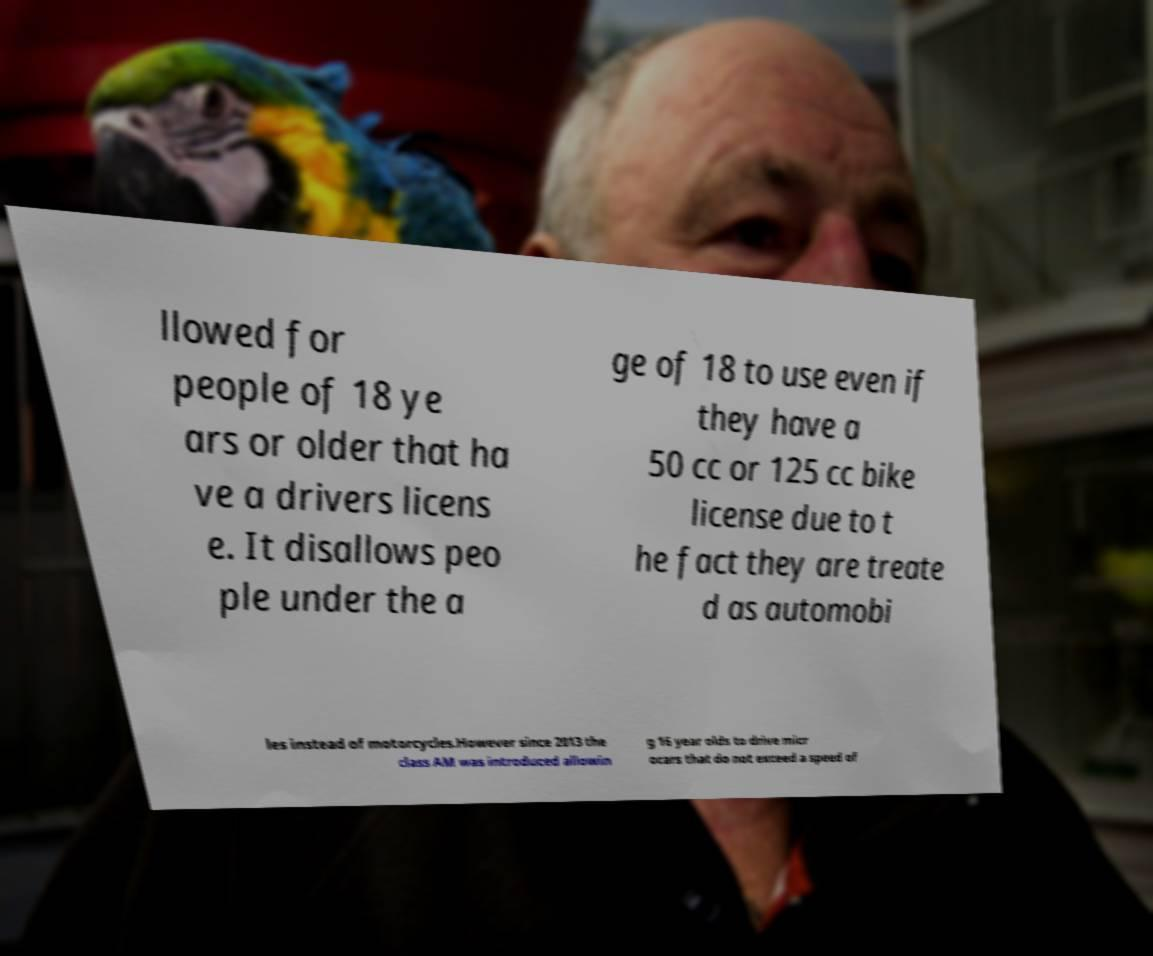Can you accurately transcribe the text from the provided image for me? llowed for people of 18 ye ars or older that ha ve a drivers licens e. It disallows peo ple under the a ge of 18 to use even if they have a 50 cc or 125 cc bike license due to t he fact they are treate d as automobi les instead of motorcycles.However since 2013 the class AM was introduced allowin g 16 year olds to drive micr ocars that do not exceed a speed of 